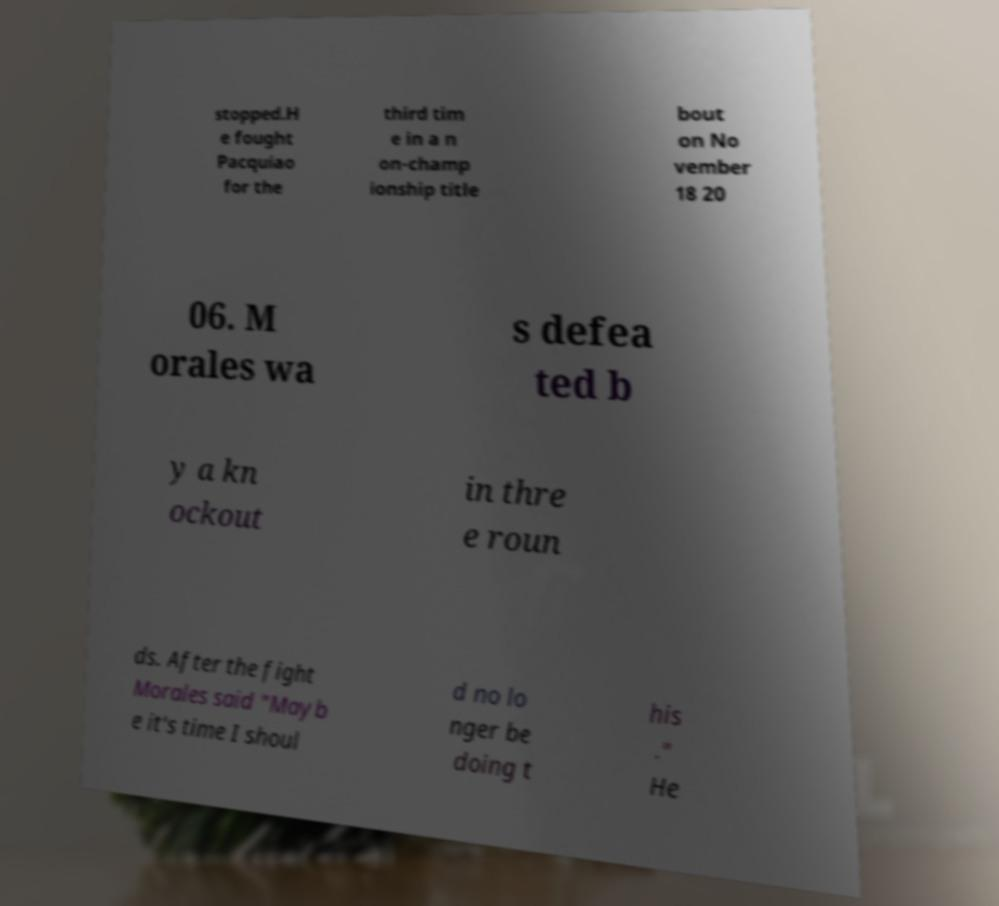Can you accurately transcribe the text from the provided image for me? stopped.H e fought Pacquiao for the third tim e in a n on-champ ionship title bout on No vember 18 20 06. M orales wa s defea ted b y a kn ockout in thre e roun ds. After the fight Morales said "Mayb e it's time I shoul d no lo nger be doing t his ." He 